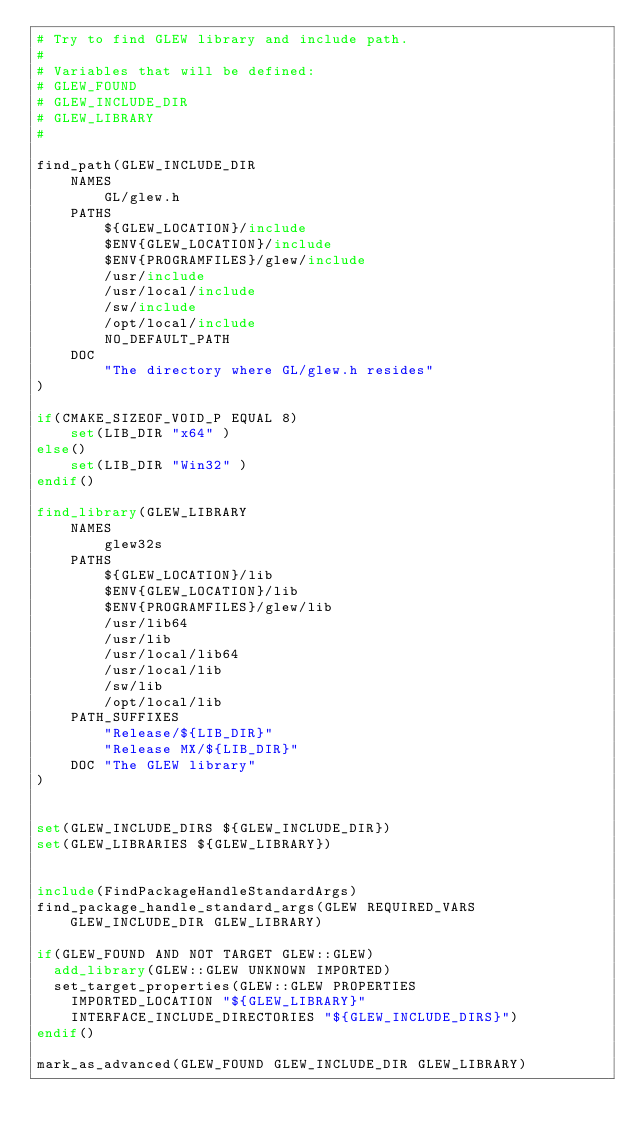Convert code to text. <code><loc_0><loc_0><loc_500><loc_500><_CMake_># Try to find GLEW library and include path.
#
# Variables that will be defined:
# GLEW_FOUND
# GLEW_INCLUDE_DIR
# GLEW_LIBRARY
#

find_path(GLEW_INCLUDE_DIR
    NAMES
        GL/glew.h
    PATHS
        ${GLEW_LOCATION}/include
        $ENV{GLEW_LOCATION}/include
        $ENV{PROGRAMFILES}/glew/include
        /usr/include
        /usr/local/include
        /sw/include
        /opt/local/include
        NO_DEFAULT_PATH
    DOC
        "The directory where GL/glew.h resides"
)

if(CMAKE_SIZEOF_VOID_P EQUAL 8)
    set(LIB_DIR "x64" )
else()
    set(LIB_DIR "Win32" )
endif()

find_library(GLEW_LIBRARY
    NAMES
        glew32s
    PATHS
        ${GLEW_LOCATION}/lib
        $ENV{GLEW_LOCATION}/lib
        $ENV{PROGRAMFILES}/glew/lib
        /usr/lib64
        /usr/lib
        /usr/local/lib64
        /usr/local/lib
        /sw/lib
        /opt/local/lib
    PATH_SUFFIXES
        "Release/${LIB_DIR}"
        "Release MX/${LIB_DIR}"
    DOC "The GLEW library"
)


set(GLEW_INCLUDE_DIRS ${GLEW_INCLUDE_DIR})
set(GLEW_LIBRARIES ${GLEW_LIBRARY})


include(FindPackageHandleStandardArgs)
find_package_handle_standard_args(GLEW REQUIRED_VARS GLEW_INCLUDE_DIR GLEW_LIBRARY)

if(GLEW_FOUND AND NOT TARGET GLEW::GLEW)
  add_library(GLEW::GLEW UNKNOWN IMPORTED)
  set_target_properties(GLEW::GLEW PROPERTIES
    IMPORTED_LOCATION "${GLEW_LIBRARY}"
    INTERFACE_INCLUDE_DIRECTORIES "${GLEW_INCLUDE_DIRS}")
endif()

mark_as_advanced(GLEW_FOUND GLEW_INCLUDE_DIR GLEW_LIBRARY)

</code> 